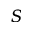<formula> <loc_0><loc_0><loc_500><loc_500>S</formula> 